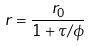Convert formula to latex. <formula><loc_0><loc_0><loc_500><loc_500>r = \frac { r _ { 0 } } { 1 + \tau / \phi }</formula> 